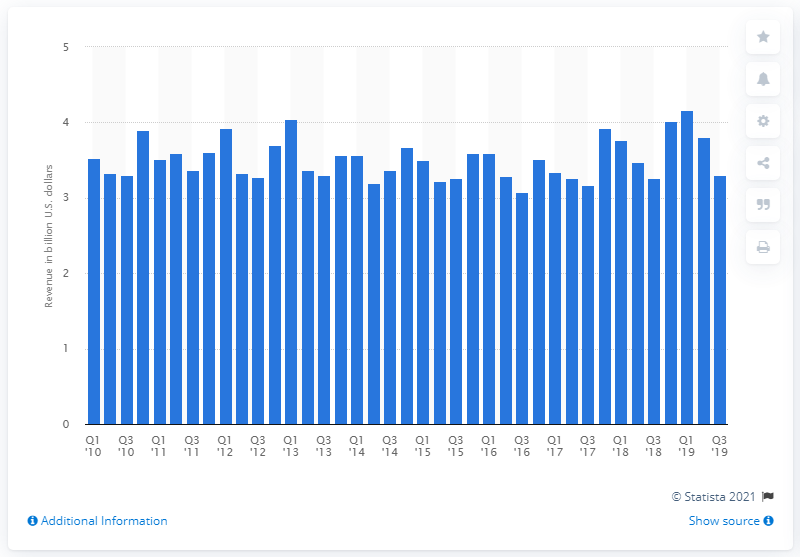Highlight a few significant elements in this photo. The global revenue of the CBS Corporation in the third quarter of 2019 was 3.3 billion dollars. The revenue generated by CBS per quarter is 3.3. The average quarterly net income of CBS is 3.3. 